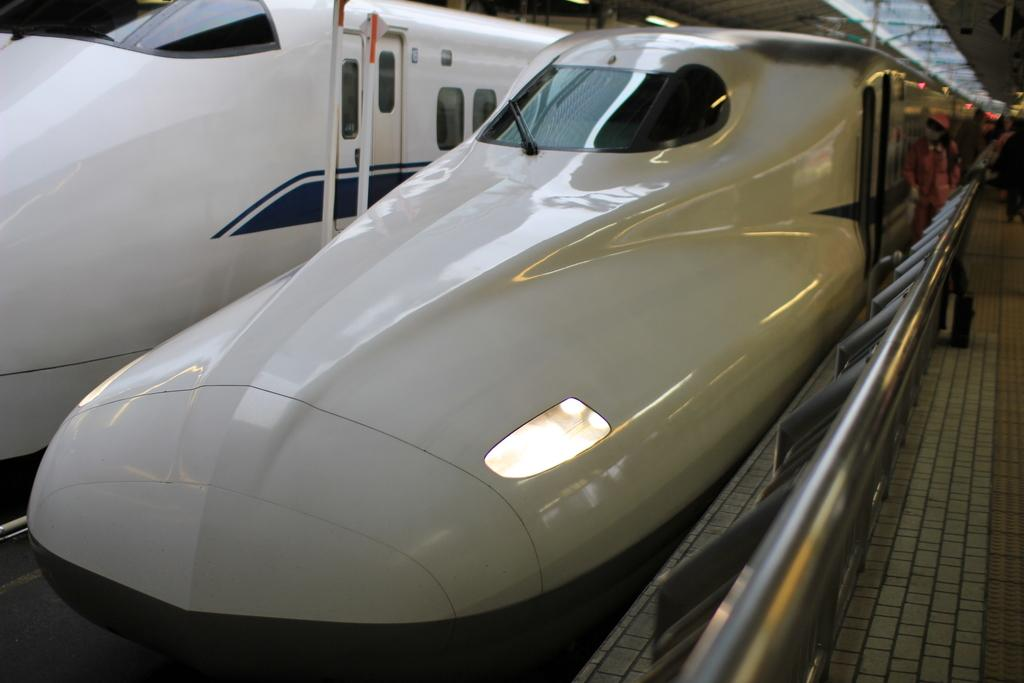What type of transportation can be seen in the image? There are two bullet trains in the image. What is the setting of the image? There is a group of people standing on a platform. What type of structure is present in the image? There are iron grilles in the image. How does the image make you feel in terms of comfort? The image itself does not evoke feelings of comfort or discomfort, as it is a static representation of a scene. 